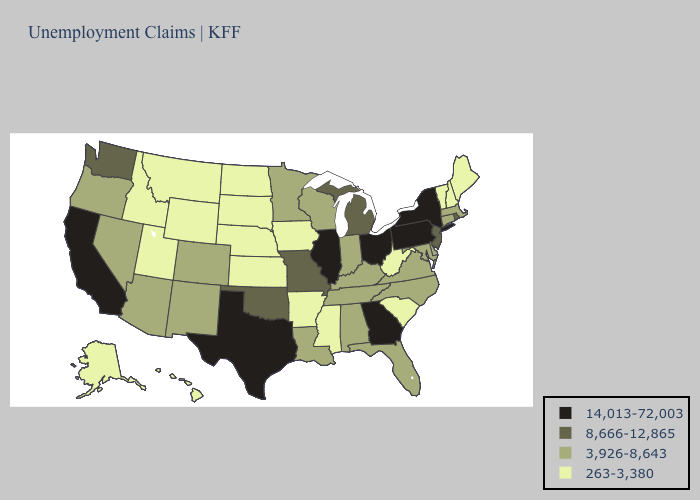Among the states that border Indiana , does Michigan have the highest value?
Be succinct. No. Which states have the lowest value in the USA?
Write a very short answer. Alaska, Arkansas, Hawaii, Idaho, Iowa, Kansas, Maine, Mississippi, Montana, Nebraska, New Hampshire, North Dakota, South Carolina, South Dakota, Utah, Vermont, West Virginia, Wyoming. Name the states that have a value in the range 8,666-12,865?
Answer briefly. Michigan, Missouri, New Jersey, Oklahoma, Rhode Island, Washington. Does Michigan have the lowest value in the USA?
Short answer required. No. Does the first symbol in the legend represent the smallest category?
Write a very short answer. No. Is the legend a continuous bar?
Give a very brief answer. No. Name the states that have a value in the range 14,013-72,003?
Give a very brief answer. California, Georgia, Illinois, New York, Ohio, Pennsylvania, Texas. What is the value of Hawaii?
Keep it brief. 263-3,380. What is the value of Wyoming?
Quick response, please. 263-3,380. Does Alabama have the same value as North Carolina?
Keep it brief. Yes. Does Oklahoma have the same value as Missouri?
Quick response, please. Yes. What is the lowest value in the South?
Short answer required. 263-3,380. What is the highest value in states that border Wyoming?
Be succinct. 3,926-8,643. Among the states that border Nebraska , which have the lowest value?
Write a very short answer. Iowa, Kansas, South Dakota, Wyoming. Name the states that have a value in the range 3,926-8,643?
Give a very brief answer. Alabama, Arizona, Colorado, Connecticut, Delaware, Florida, Indiana, Kentucky, Louisiana, Maryland, Massachusetts, Minnesota, Nevada, New Mexico, North Carolina, Oregon, Tennessee, Virginia, Wisconsin. 